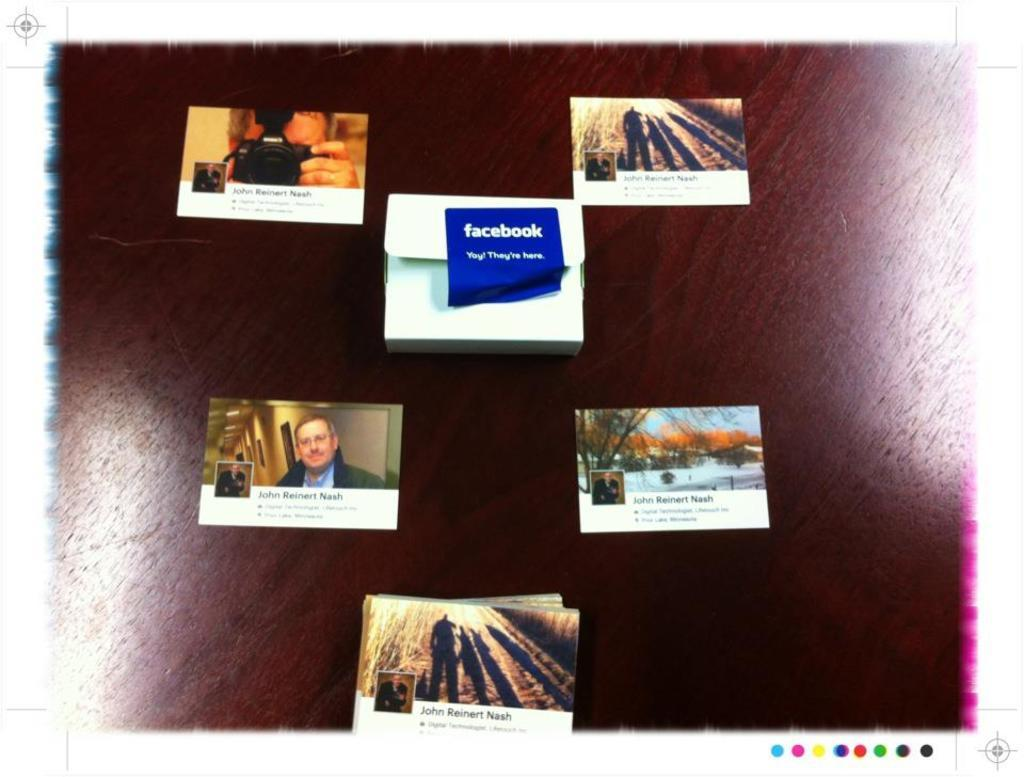<image>
Present a compact description of the photo's key features. A collage of pictures with the one in the center being a picture of the facebook logo. 